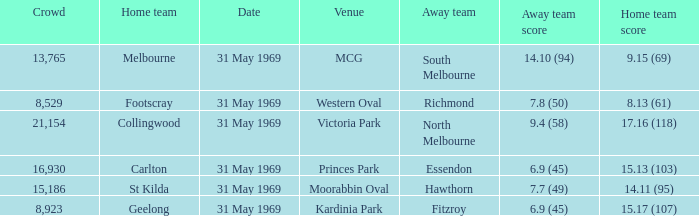17 (107), who was the visiting team? Fitzroy. 